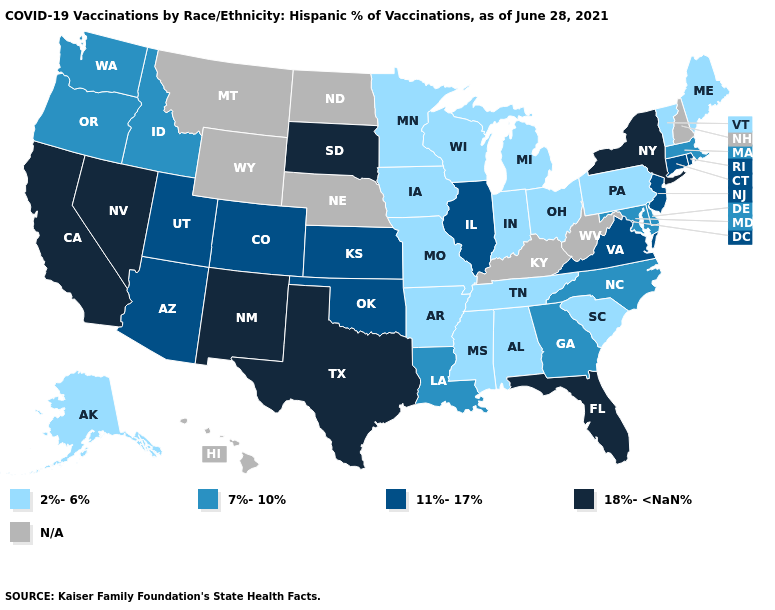Which states have the highest value in the USA?
Give a very brief answer. California, Florida, Nevada, New Mexico, New York, South Dakota, Texas. What is the highest value in the West ?
Concise answer only. 18%-<NaN%. Does Oklahoma have the highest value in the USA?
Write a very short answer. No. Name the states that have a value in the range 11%-17%?
Quick response, please. Arizona, Colorado, Connecticut, Illinois, Kansas, New Jersey, Oklahoma, Rhode Island, Utah, Virginia. Among the states that border Oklahoma , does Texas have the highest value?
Concise answer only. Yes. Name the states that have a value in the range 18%-<NaN%?
Be succinct. California, Florida, Nevada, New Mexico, New York, South Dakota, Texas. What is the highest value in states that border Nevada?
Short answer required. 18%-<NaN%. What is the value of West Virginia?
Answer briefly. N/A. Which states have the highest value in the USA?
Keep it brief. California, Florida, Nevada, New Mexico, New York, South Dakota, Texas. What is the lowest value in the Northeast?
Be succinct. 2%-6%. What is the lowest value in the Northeast?
Concise answer only. 2%-6%. 